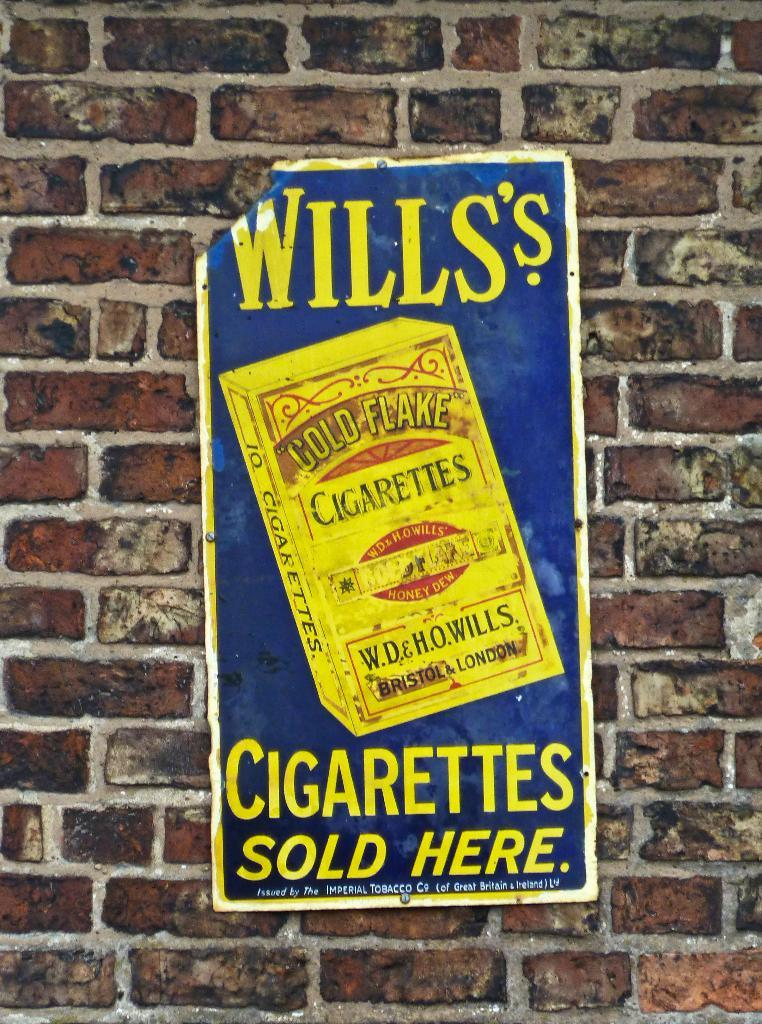<image>
Share a concise interpretation of the image provided. A poster on a brick wall for Will's cigarettes. 